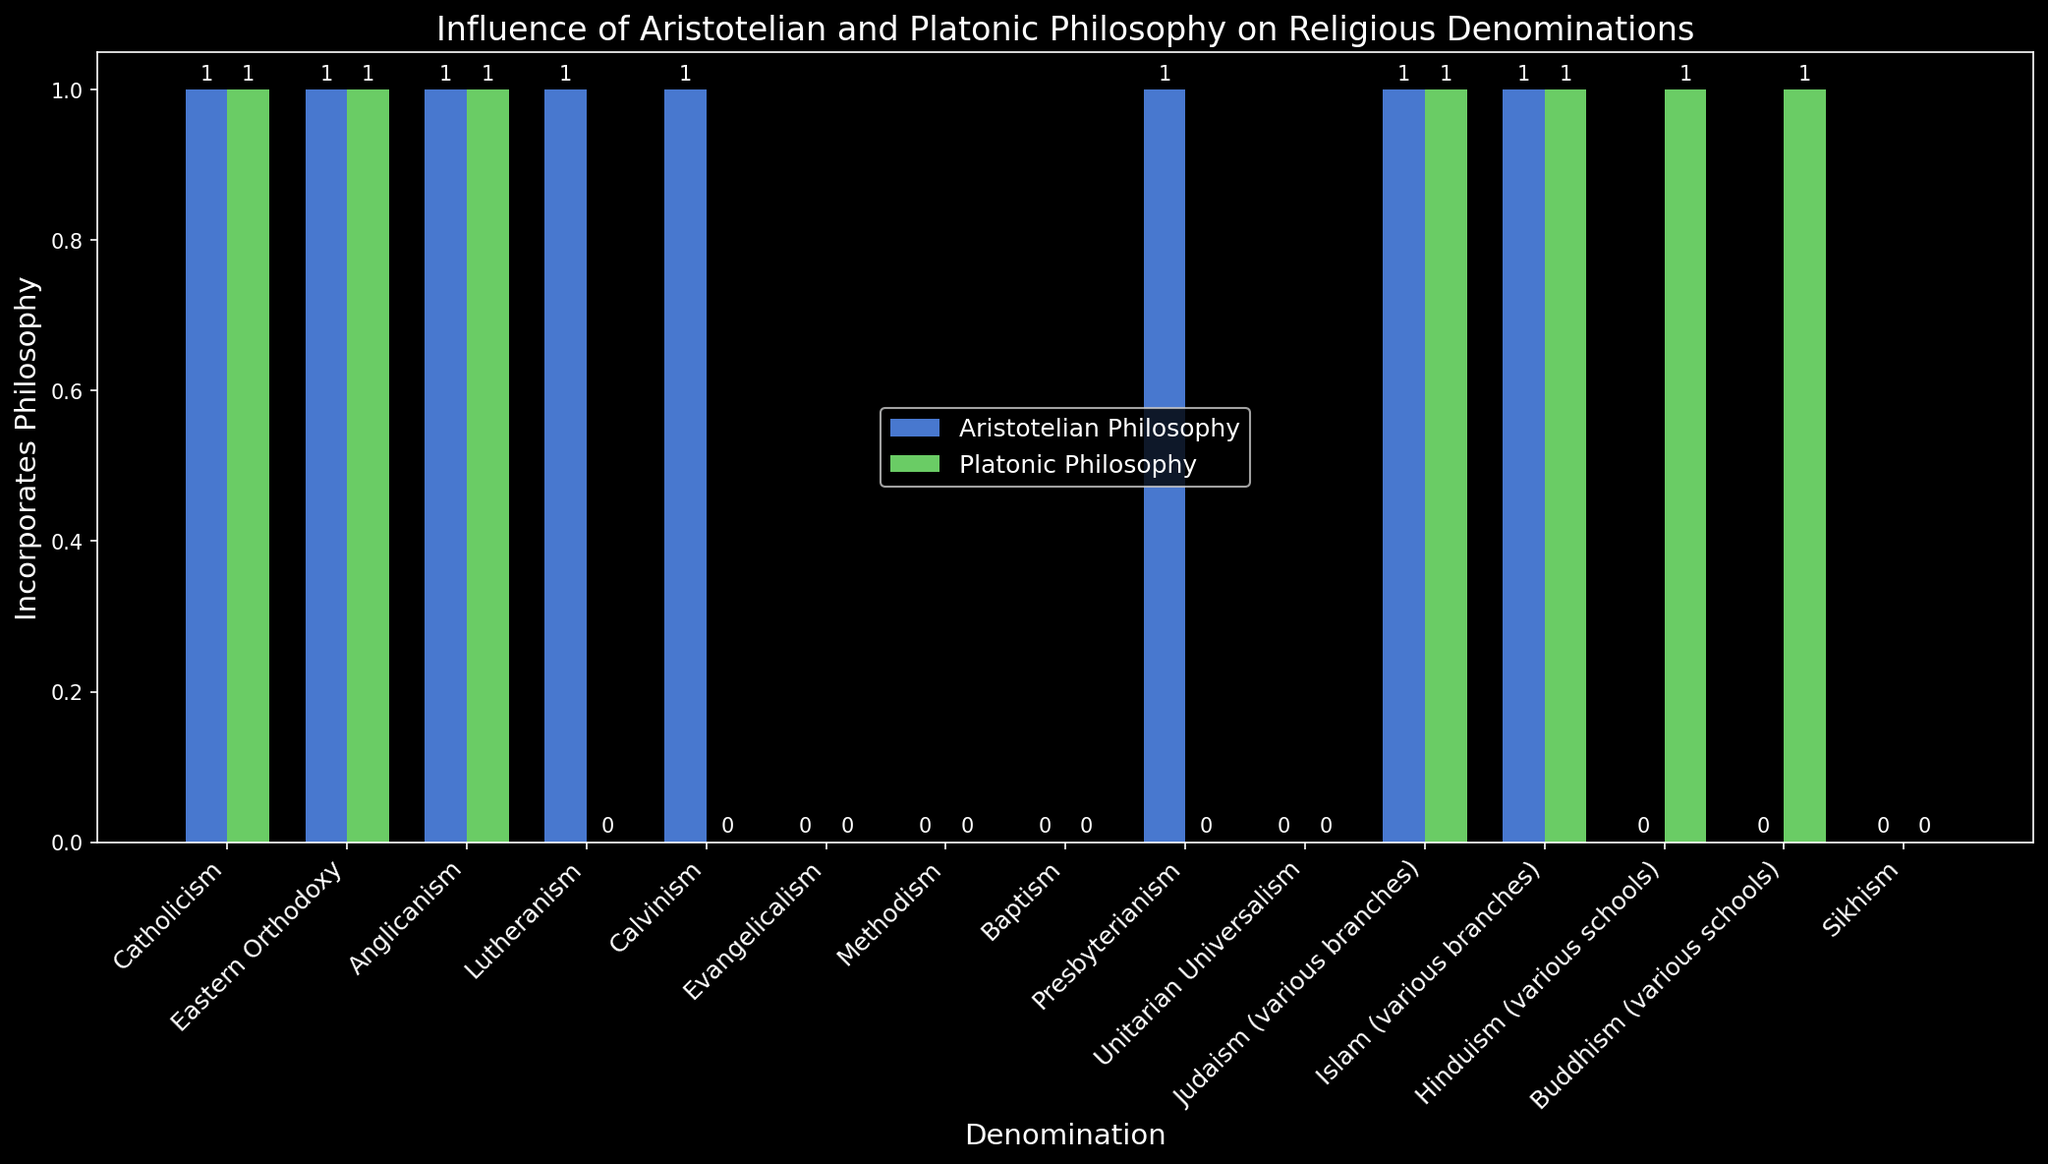Which denominations incorporate both Aristotelian and Platonic Philosophy? By looking at the bars representing Aristotelian and Platonic philosophies, we identify the denominations where both bars are present (value of 1). These are Catholicism, Eastern Orthodoxy, Anglicanism, Judaism (various branches), and Islam (various branches).
Answer: Catholicism, Eastern Orthodoxy, Anglicanism, Judaism (various branches), Islam (various branches) Which denominations do not incorporate either Aristotelian or Platonic Philosophy? By identifying denominations where both bars are absent (value of 0), we find Evangelicalism, Methodism, Baptism, Unitarian Universalism, and Sikhism.
Answer: Evangelicalism, Methodism, Baptism, Unitarian Universalism, Sikhism How many denominations incorporate Aristotelian Philosophy but not Platonic Philosophy? We count the denominations where the bar for Aristotelian philosophy is present (value of 1) and the bar for Platonic philosophy is absent (value of 0). These are Lutheranism, Calvinism, and Presbyterianism.
Answer: 3 Which philosophy is incorporated by more denominations? By adding the total bars for Aristotelian and Platonic philosophies across all denominations, Aristotelian is adopted by 8 denominations while Platonic is adopted by 6. Thus, Aristotelian philosophy is incorporated by more denominations.
Answer: Aristotelian What is the difference in the number of denominations incorporating Aristotelian Philosophy and those incorporating Platonic Philosophy? From the figure, we know Aristotelian philosophy is incorporated by 8 denominations, and Platonic philosophy by 6. The difference is 8 - 6 = 2.
Answer: 2 Which denominations incorporate Platonic but not Aristotelian Philosophy? We look for denominations where the bar for Platonic philosophy is present (value of 1) and the bar for Aristotelian philosophy is absent (value of 0). These are Hinduism and Buddhism (various schools).
Answer: Hinduism, Buddhism (various schools) How many total denominations are shown in the figure? By counting the number of bars (total denominations listed on the x-axis), we find there are 15 denominations.
Answer: 15 Between Catholicism and Islam (various branches), which has a higher influence of Aristotelian Philosophy? From visual inspection, both denominations show an equal influence of Aristotelian Philosophy (both have a bar value of 1 for Aristotelian).
Answer: Equal What is the combined total of denominations that incorporate either Aristotelian or Platonic Philosophy? Add the total number of denominations incorporating Aristotelian (8) and Platonic (6), but subtract the count of denominations incorporating both (5) to avoid double-counting. Resulting total is 8 + 6 - 5 = 9.
Answer: 9 